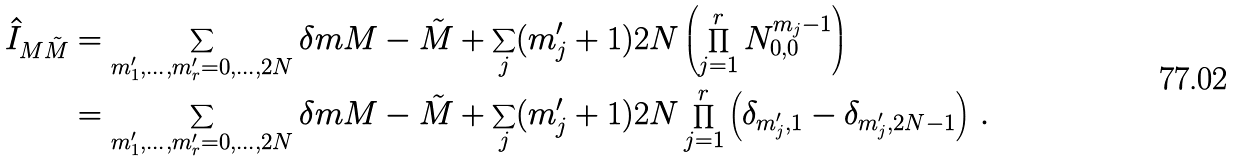<formula> <loc_0><loc_0><loc_500><loc_500>\hat { I } _ { M \tilde { M } } & = \sum _ { m _ { 1 } ^ { \prime } , \dots , m _ { r } ^ { \prime } = 0 , \dots , 2 N } \delta m { M - \tilde { M } + \sum _ { j } ( m _ { j } ^ { \prime } + 1 ) } { 2 N } \left ( \prod _ { j = 1 } ^ { r } N _ { 0 , 0 } ^ { m _ { j } - 1 } \right ) \\ & = \sum _ { m _ { 1 } ^ { \prime } , \dots , m _ { r } ^ { \prime } = 0 , \dots , 2 N } \delta m { M - \tilde { M } + \sum _ { j } ( m _ { j } ^ { \prime } + 1 ) } { 2 N } \prod _ { j = 1 } ^ { r } \left ( \delta _ { m _ { j } ^ { \prime } , 1 } - \delta _ { m _ { j } ^ { \prime } , 2 N - 1 } \right ) \, .</formula> 